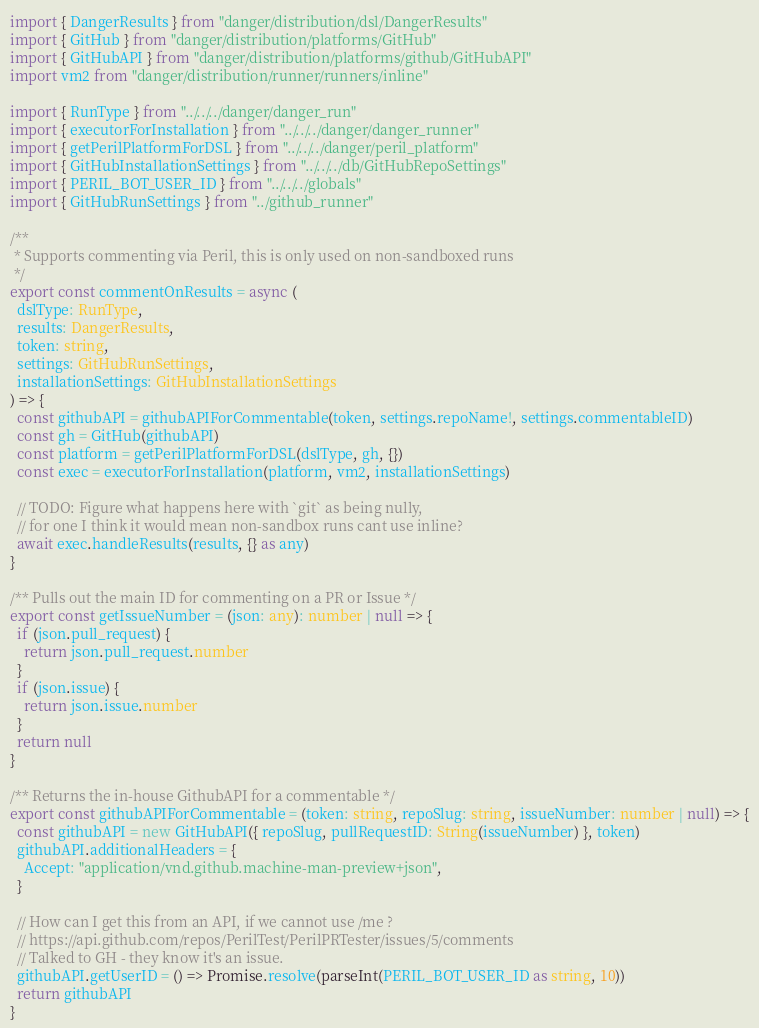<code> <loc_0><loc_0><loc_500><loc_500><_TypeScript_>import { DangerResults } from "danger/distribution/dsl/DangerResults"
import { GitHub } from "danger/distribution/platforms/GitHub"
import { GitHubAPI } from "danger/distribution/platforms/github/GitHubAPI"
import vm2 from "danger/distribution/runner/runners/inline"

import { RunType } from "../../../danger/danger_run"
import { executorForInstallation } from "../../../danger/danger_runner"
import { getPerilPlatformForDSL } from "../../../danger/peril_platform"
import { GitHubInstallationSettings } from "../../../db/GitHubRepoSettings"
import { PERIL_BOT_USER_ID } from "../../../globals"
import { GitHubRunSettings } from "../github_runner"

/**
 * Supports commenting via Peril, this is only used on non-sandboxed runs
 */
export const commentOnResults = async (
  dslType: RunType,
  results: DangerResults,
  token: string,
  settings: GitHubRunSettings,
  installationSettings: GitHubInstallationSettings
) => {
  const githubAPI = githubAPIForCommentable(token, settings.repoName!, settings.commentableID)
  const gh = GitHub(githubAPI)
  const platform = getPerilPlatformForDSL(dslType, gh, {})
  const exec = executorForInstallation(platform, vm2, installationSettings)

  // TODO: Figure what happens here with `git` as being nully,
  // for one I think it would mean non-sandbox runs cant use inline?
  await exec.handleResults(results, {} as any)
}

/** Pulls out the main ID for commenting on a PR or Issue */
export const getIssueNumber = (json: any): number | null => {
  if (json.pull_request) {
    return json.pull_request.number
  }
  if (json.issue) {
    return json.issue.number
  }
  return null
}

/** Returns the in-house GithubAPI for a commentable */
export const githubAPIForCommentable = (token: string, repoSlug: string, issueNumber: number | null) => {
  const githubAPI = new GitHubAPI({ repoSlug, pullRequestID: String(issueNumber) }, token)
  githubAPI.additionalHeaders = {
    Accept: "application/vnd.github.machine-man-preview+json",
  }

  // How can I get this from an API, if we cannot use /me ?
  // https://api.github.com/repos/PerilTest/PerilPRTester/issues/5/comments
  // Talked to GH - they know it's an issue.
  githubAPI.getUserID = () => Promise.resolve(parseInt(PERIL_BOT_USER_ID as string, 10))
  return githubAPI
}
</code> 